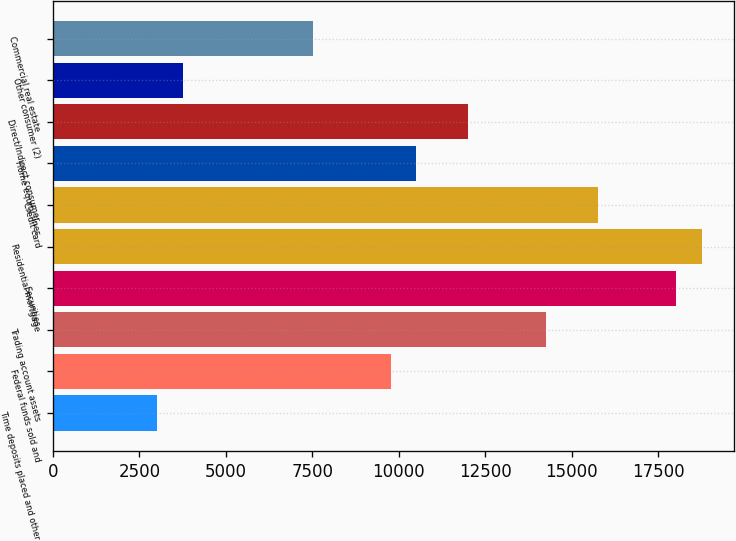Convert chart. <chart><loc_0><loc_0><loc_500><loc_500><bar_chart><fcel>Time deposits placed and other<fcel>Federal funds sold and<fcel>Trading account assets<fcel>Securities<fcel>Residential mortgage<fcel>Credit card<fcel>Home equity lines<fcel>Direct/Indirect consumer<fcel>Other consumer (2)<fcel>Commercial real estate<nl><fcel>3020<fcel>9765.5<fcel>14262.5<fcel>18010<fcel>18759.5<fcel>15761.5<fcel>10515<fcel>12014<fcel>3769.5<fcel>7517<nl></chart> 